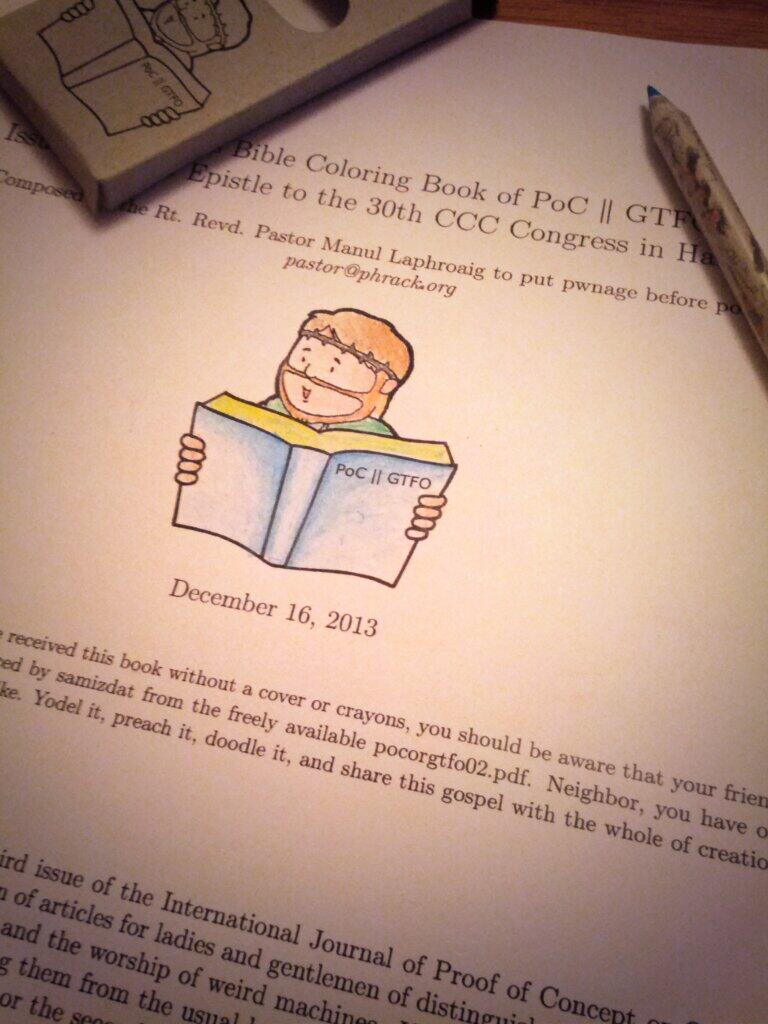<image>
Create a compact narrative representing the image presented. A pen sits on a table next to a page from a Bible themed coloring book. 